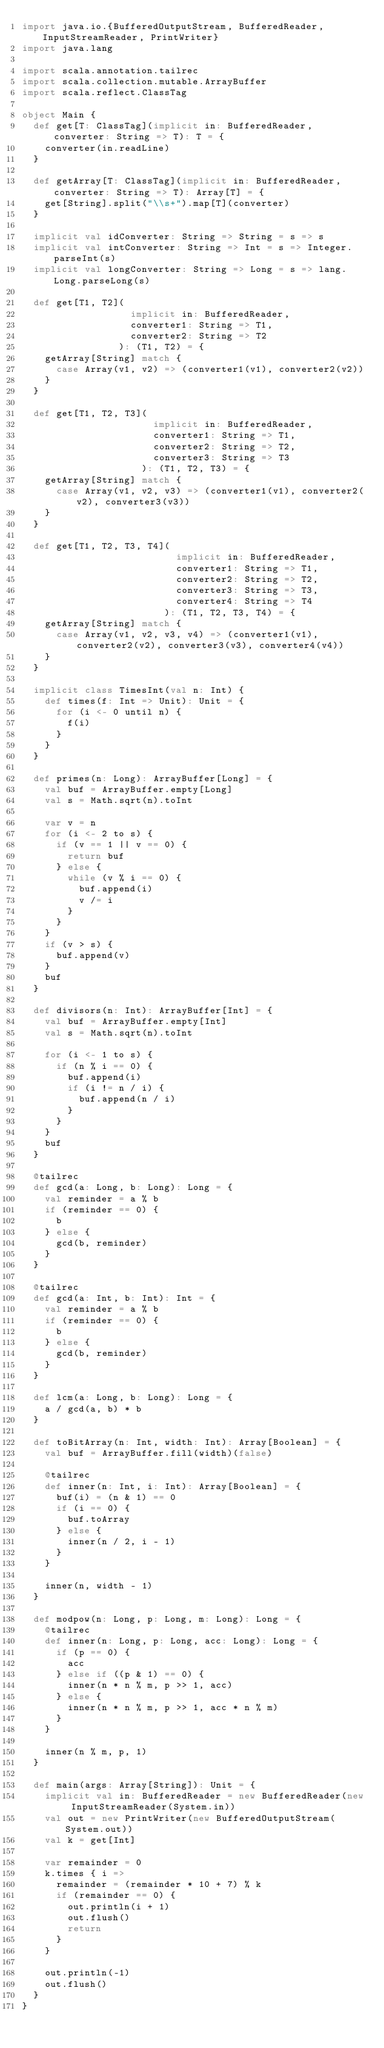Convert code to text. <code><loc_0><loc_0><loc_500><loc_500><_Scala_>import java.io.{BufferedOutputStream, BufferedReader, InputStreamReader, PrintWriter}
import java.lang

import scala.annotation.tailrec
import scala.collection.mutable.ArrayBuffer
import scala.reflect.ClassTag

object Main {
  def get[T: ClassTag](implicit in: BufferedReader, converter: String => T): T = {
    converter(in.readLine)
  }

  def getArray[T: ClassTag](implicit in: BufferedReader, converter: String => T): Array[T] = {
    get[String].split("\\s+").map[T](converter)
  }

  implicit val idConverter: String => String = s => s
  implicit val intConverter: String => Int = s => Integer.parseInt(s)
  implicit val longConverter: String => Long = s => lang.Long.parseLong(s)

  def get[T1, T2](
                   implicit in: BufferedReader,
                   converter1: String => T1,
                   converter2: String => T2
                 ): (T1, T2) = {
    getArray[String] match {
      case Array(v1, v2) => (converter1(v1), converter2(v2))
    }
  }

  def get[T1, T2, T3](
                       implicit in: BufferedReader,
                       converter1: String => T1,
                       converter2: String => T2,
                       converter3: String => T3
                     ): (T1, T2, T3) = {
    getArray[String] match {
      case Array(v1, v2, v3) => (converter1(v1), converter2(v2), converter3(v3))
    }
  }

  def get[T1, T2, T3, T4](
                           implicit in: BufferedReader,
                           converter1: String => T1,
                           converter2: String => T2,
                           converter3: String => T3,
                           converter4: String => T4
                         ): (T1, T2, T3, T4) = {
    getArray[String] match {
      case Array(v1, v2, v3, v4) => (converter1(v1), converter2(v2), converter3(v3), converter4(v4))
    }
  }

  implicit class TimesInt(val n: Int) {
    def times(f: Int => Unit): Unit = {
      for (i <- 0 until n) {
        f(i)
      }
    }
  }

  def primes(n: Long): ArrayBuffer[Long] = {
    val buf = ArrayBuffer.empty[Long]
    val s = Math.sqrt(n).toInt

    var v = n
    for (i <- 2 to s) {
      if (v == 1 || v == 0) {
        return buf
      } else {
        while (v % i == 0) {
          buf.append(i)
          v /= i
        }
      }
    }
    if (v > s) {
      buf.append(v)
    }
    buf
  }

  def divisors(n: Int): ArrayBuffer[Int] = {
    val buf = ArrayBuffer.empty[Int]
    val s = Math.sqrt(n).toInt

    for (i <- 1 to s) {
      if (n % i == 0) {
        buf.append(i)
        if (i != n / i) {
          buf.append(n / i)
        }
      }
    }
    buf
  }

  @tailrec
  def gcd(a: Long, b: Long): Long = {
    val reminder = a % b
    if (reminder == 0) {
      b
    } else {
      gcd(b, reminder)
    }
  }

  @tailrec
  def gcd(a: Int, b: Int): Int = {
    val reminder = a % b
    if (reminder == 0) {
      b
    } else {
      gcd(b, reminder)
    }
  }

  def lcm(a: Long, b: Long): Long = {
    a / gcd(a, b) * b
  }

  def toBitArray(n: Int, width: Int): Array[Boolean] = {
    val buf = ArrayBuffer.fill(width)(false)

    @tailrec
    def inner(n: Int, i: Int): Array[Boolean] = {
      buf(i) = (n & 1) == 0
      if (i == 0) {
        buf.toArray
      } else {
        inner(n / 2, i - 1)
      }
    }

    inner(n, width - 1)
  }

  def modpow(n: Long, p: Long, m: Long): Long = {
    @tailrec
    def inner(n: Long, p: Long, acc: Long): Long = {
      if (p == 0) {
        acc
      } else if ((p & 1) == 0) {
        inner(n * n % m, p >> 1, acc)
      } else {
        inner(n * n % m, p >> 1, acc * n % m)
      }
    }

    inner(n % m, p, 1)
  }

  def main(args: Array[String]): Unit = {
    implicit val in: BufferedReader = new BufferedReader(new InputStreamReader(System.in))
    val out = new PrintWriter(new BufferedOutputStream(System.out))
    val k = get[Int]

    var remainder = 0
    k.times { i =>
      remainder = (remainder * 10 + 7) % k
      if (remainder == 0) {
        out.println(i + 1)
        out.flush()
        return
      }
    }

    out.println(-1)
    out.flush()
  }
}</code> 